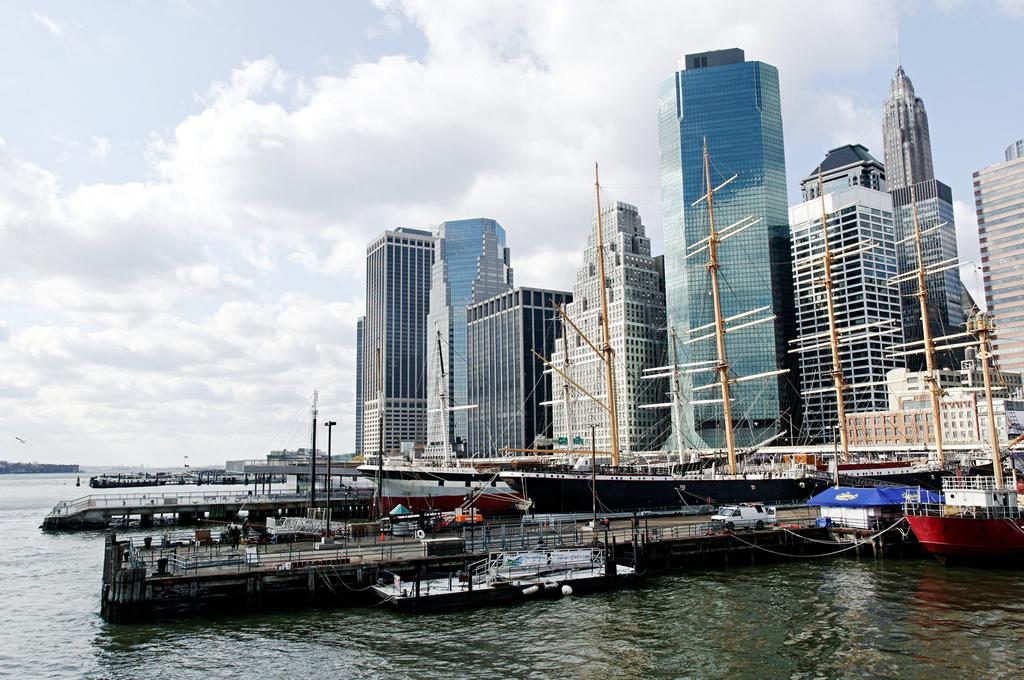What type of vehicles can be seen in the image? There is a vehicle in the image. What other structures or objects are present in the image? There are ships, buildings, and poles visible in the image. What is the condition of the water in the image? The water is visible at the bottom of the image. How would you describe the sky in the background of the image? The sky is cloudy in the background of the image. What type of bean is being used as a prop in the image? There is no bean present in the image. Can you hear the voice of the person operating the vehicle in the image? The image is silent, so it is not possible to hear any voices. 